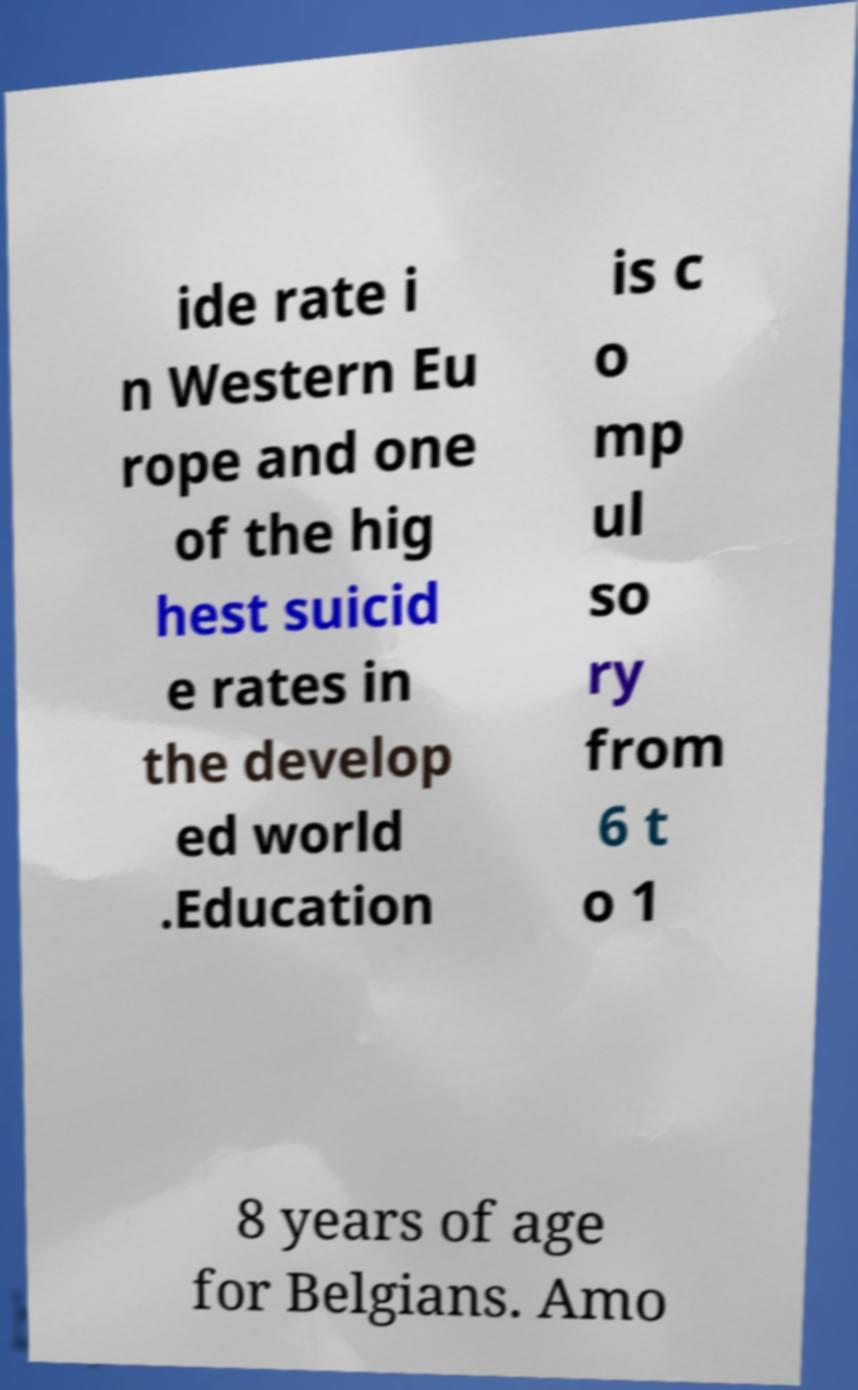Please read and relay the text visible in this image. What does it say? ide rate i n Western Eu rope and one of the hig hest suicid e rates in the develop ed world .Education is c o mp ul so ry from 6 t o 1 8 years of age for Belgians. Amo 